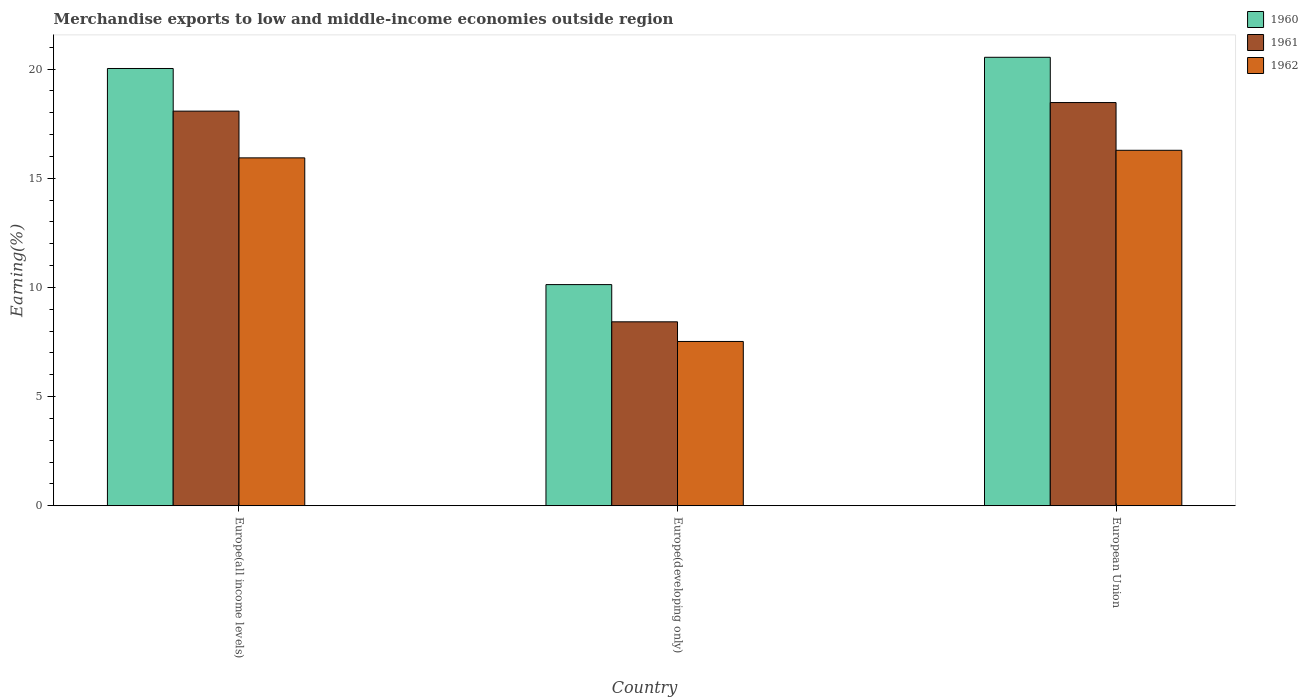How many bars are there on the 2nd tick from the left?
Offer a terse response. 3. How many bars are there on the 1st tick from the right?
Offer a terse response. 3. What is the label of the 3rd group of bars from the left?
Your answer should be very brief. European Union. In how many cases, is the number of bars for a given country not equal to the number of legend labels?
Keep it short and to the point. 0. What is the percentage of amount earned from merchandise exports in 1960 in Europe(developing only)?
Provide a succinct answer. 10.13. Across all countries, what is the maximum percentage of amount earned from merchandise exports in 1961?
Ensure brevity in your answer.  18.46. Across all countries, what is the minimum percentage of amount earned from merchandise exports in 1962?
Your answer should be compact. 7.52. In which country was the percentage of amount earned from merchandise exports in 1961 maximum?
Your answer should be compact. European Union. In which country was the percentage of amount earned from merchandise exports in 1961 minimum?
Provide a short and direct response. Europe(developing only). What is the total percentage of amount earned from merchandise exports in 1960 in the graph?
Ensure brevity in your answer.  50.69. What is the difference between the percentage of amount earned from merchandise exports in 1960 in Europe(developing only) and that in European Union?
Your answer should be very brief. -10.41. What is the difference between the percentage of amount earned from merchandise exports in 1960 in Europe(developing only) and the percentage of amount earned from merchandise exports in 1961 in European Union?
Your answer should be very brief. -8.34. What is the average percentage of amount earned from merchandise exports in 1960 per country?
Ensure brevity in your answer.  16.9. What is the difference between the percentage of amount earned from merchandise exports of/in 1960 and percentage of amount earned from merchandise exports of/in 1962 in Europe(developing only)?
Make the answer very short. 2.6. In how many countries, is the percentage of amount earned from merchandise exports in 1960 greater than 20 %?
Provide a short and direct response. 2. What is the ratio of the percentage of amount earned from merchandise exports in 1960 in Europe(all income levels) to that in Europe(developing only)?
Provide a short and direct response. 1.98. What is the difference between the highest and the second highest percentage of amount earned from merchandise exports in 1961?
Offer a terse response. -10.04. What is the difference between the highest and the lowest percentage of amount earned from merchandise exports in 1962?
Your answer should be very brief. 8.76. Is the sum of the percentage of amount earned from merchandise exports in 1960 in Europe(all income levels) and Europe(developing only) greater than the maximum percentage of amount earned from merchandise exports in 1961 across all countries?
Provide a short and direct response. Yes. What does the 3rd bar from the left in European Union represents?
Provide a succinct answer. 1962. What does the 1st bar from the right in Europe(developing only) represents?
Your response must be concise. 1962. Is it the case that in every country, the sum of the percentage of amount earned from merchandise exports in 1961 and percentage of amount earned from merchandise exports in 1960 is greater than the percentage of amount earned from merchandise exports in 1962?
Your response must be concise. Yes. How many bars are there?
Give a very brief answer. 9. Are all the bars in the graph horizontal?
Offer a terse response. No. How many countries are there in the graph?
Your response must be concise. 3. Does the graph contain grids?
Offer a terse response. No. Where does the legend appear in the graph?
Your response must be concise. Top right. How are the legend labels stacked?
Offer a terse response. Vertical. What is the title of the graph?
Offer a very short reply. Merchandise exports to low and middle-income economies outside region. Does "1997" appear as one of the legend labels in the graph?
Offer a very short reply. No. What is the label or title of the X-axis?
Keep it short and to the point. Country. What is the label or title of the Y-axis?
Your answer should be very brief. Earning(%). What is the Earning(%) in 1960 in Europe(all income levels)?
Give a very brief answer. 20.02. What is the Earning(%) of 1961 in Europe(all income levels)?
Give a very brief answer. 18.07. What is the Earning(%) of 1962 in Europe(all income levels)?
Ensure brevity in your answer.  15.93. What is the Earning(%) of 1960 in Europe(developing only)?
Ensure brevity in your answer.  10.13. What is the Earning(%) of 1961 in Europe(developing only)?
Keep it short and to the point. 8.42. What is the Earning(%) in 1962 in Europe(developing only)?
Ensure brevity in your answer.  7.52. What is the Earning(%) of 1960 in European Union?
Provide a succinct answer. 20.54. What is the Earning(%) of 1961 in European Union?
Provide a short and direct response. 18.46. What is the Earning(%) in 1962 in European Union?
Ensure brevity in your answer.  16.28. Across all countries, what is the maximum Earning(%) of 1960?
Provide a short and direct response. 20.54. Across all countries, what is the maximum Earning(%) in 1961?
Provide a short and direct response. 18.46. Across all countries, what is the maximum Earning(%) of 1962?
Make the answer very short. 16.28. Across all countries, what is the minimum Earning(%) of 1960?
Provide a succinct answer. 10.13. Across all countries, what is the minimum Earning(%) in 1961?
Ensure brevity in your answer.  8.42. Across all countries, what is the minimum Earning(%) of 1962?
Offer a very short reply. 7.52. What is the total Earning(%) in 1960 in the graph?
Provide a succinct answer. 50.69. What is the total Earning(%) of 1961 in the graph?
Offer a very short reply. 44.96. What is the total Earning(%) in 1962 in the graph?
Give a very brief answer. 39.73. What is the difference between the Earning(%) of 1960 in Europe(all income levels) and that in Europe(developing only)?
Give a very brief answer. 9.9. What is the difference between the Earning(%) of 1961 in Europe(all income levels) and that in Europe(developing only)?
Offer a terse response. 9.65. What is the difference between the Earning(%) in 1962 in Europe(all income levels) and that in Europe(developing only)?
Provide a succinct answer. 8.41. What is the difference between the Earning(%) of 1960 in Europe(all income levels) and that in European Union?
Provide a succinct answer. -0.51. What is the difference between the Earning(%) in 1961 in Europe(all income levels) and that in European Union?
Provide a succinct answer. -0.39. What is the difference between the Earning(%) in 1962 in Europe(all income levels) and that in European Union?
Your answer should be very brief. -0.35. What is the difference between the Earning(%) of 1960 in Europe(developing only) and that in European Union?
Provide a succinct answer. -10.41. What is the difference between the Earning(%) in 1961 in Europe(developing only) and that in European Union?
Ensure brevity in your answer.  -10.04. What is the difference between the Earning(%) in 1962 in Europe(developing only) and that in European Union?
Ensure brevity in your answer.  -8.76. What is the difference between the Earning(%) in 1960 in Europe(all income levels) and the Earning(%) in 1961 in Europe(developing only)?
Offer a very short reply. 11.6. What is the difference between the Earning(%) of 1960 in Europe(all income levels) and the Earning(%) of 1962 in Europe(developing only)?
Offer a terse response. 12.5. What is the difference between the Earning(%) in 1961 in Europe(all income levels) and the Earning(%) in 1962 in Europe(developing only)?
Give a very brief answer. 10.55. What is the difference between the Earning(%) of 1960 in Europe(all income levels) and the Earning(%) of 1961 in European Union?
Your answer should be compact. 1.56. What is the difference between the Earning(%) in 1960 in Europe(all income levels) and the Earning(%) in 1962 in European Union?
Provide a short and direct response. 3.75. What is the difference between the Earning(%) in 1961 in Europe(all income levels) and the Earning(%) in 1962 in European Union?
Offer a very short reply. 1.79. What is the difference between the Earning(%) in 1960 in Europe(developing only) and the Earning(%) in 1961 in European Union?
Offer a very short reply. -8.34. What is the difference between the Earning(%) of 1960 in Europe(developing only) and the Earning(%) of 1962 in European Union?
Your response must be concise. -6.15. What is the difference between the Earning(%) of 1961 in Europe(developing only) and the Earning(%) of 1962 in European Union?
Offer a terse response. -7.86. What is the average Earning(%) of 1960 per country?
Provide a short and direct response. 16.9. What is the average Earning(%) in 1961 per country?
Offer a very short reply. 14.99. What is the average Earning(%) of 1962 per country?
Provide a succinct answer. 13.24. What is the difference between the Earning(%) in 1960 and Earning(%) in 1961 in Europe(all income levels)?
Give a very brief answer. 1.95. What is the difference between the Earning(%) of 1960 and Earning(%) of 1962 in Europe(all income levels)?
Provide a succinct answer. 4.09. What is the difference between the Earning(%) of 1961 and Earning(%) of 1962 in Europe(all income levels)?
Your answer should be very brief. 2.14. What is the difference between the Earning(%) of 1960 and Earning(%) of 1961 in Europe(developing only)?
Your answer should be compact. 1.7. What is the difference between the Earning(%) of 1960 and Earning(%) of 1962 in Europe(developing only)?
Give a very brief answer. 2.6. What is the difference between the Earning(%) of 1961 and Earning(%) of 1962 in Europe(developing only)?
Provide a short and direct response. 0.9. What is the difference between the Earning(%) of 1960 and Earning(%) of 1961 in European Union?
Provide a succinct answer. 2.07. What is the difference between the Earning(%) in 1960 and Earning(%) in 1962 in European Union?
Make the answer very short. 4.26. What is the difference between the Earning(%) in 1961 and Earning(%) in 1962 in European Union?
Give a very brief answer. 2.19. What is the ratio of the Earning(%) in 1960 in Europe(all income levels) to that in Europe(developing only)?
Keep it short and to the point. 1.98. What is the ratio of the Earning(%) in 1961 in Europe(all income levels) to that in Europe(developing only)?
Your answer should be compact. 2.15. What is the ratio of the Earning(%) of 1962 in Europe(all income levels) to that in Europe(developing only)?
Your response must be concise. 2.12. What is the ratio of the Earning(%) in 1961 in Europe(all income levels) to that in European Union?
Provide a short and direct response. 0.98. What is the ratio of the Earning(%) of 1962 in Europe(all income levels) to that in European Union?
Ensure brevity in your answer.  0.98. What is the ratio of the Earning(%) in 1960 in Europe(developing only) to that in European Union?
Provide a short and direct response. 0.49. What is the ratio of the Earning(%) of 1961 in Europe(developing only) to that in European Union?
Provide a short and direct response. 0.46. What is the ratio of the Earning(%) of 1962 in Europe(developing only) to that in European Union?
Offer a very short reply. 0.46. What is the difference between the highest and the second highest Earning(%) of 1960?
Provide a short and direct response. 0.51. What is the difference between the highest and the second highest Earning(%) in 1961?
Provide a short and direct response. 0.39. What is the difference between the highest and the second highest Earning(%) in 1962?
Offer a very short reply. 0.35. What is the difference between the highest and the lowest Earning(%) of 1960?
Your answer should be very brief. 10.41. What is the difference between the highest and the lowest Earning(%) in 1961?
Provide a short and direct response. 10.04. What is the difference between the highest and the lowest Earning(%) in 1962?
Make the answer very short. 8.76. 